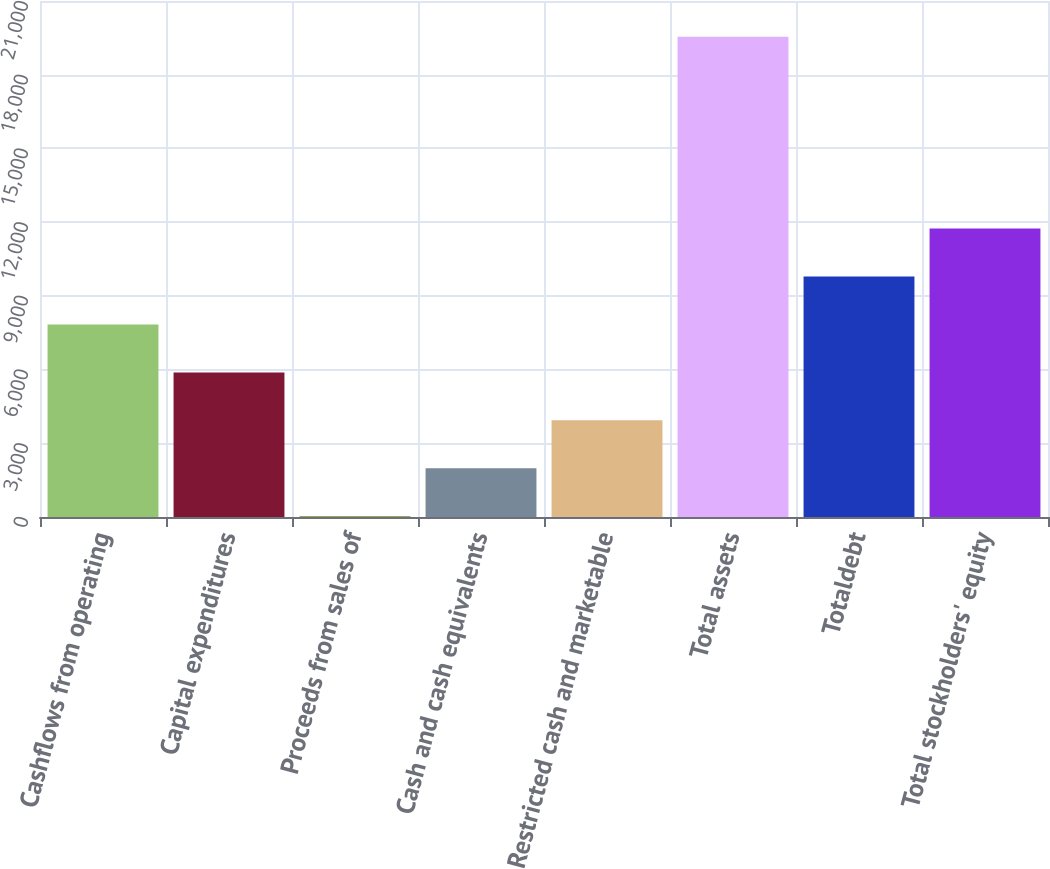Convert chart. <chart><loc_0><loc_0><loc_500><loc_500><bar_chart><fcel>Cashflows from operating<fcel>Capital expenditures<fcel>Proceeds from sales of<fcel>Cash and cash equivalents<fcel>Restricted cash and marketable<fcel>Total assets<fcel>Totaldebt<fcel>Total stockholders' equity<nl><fcel>7835.2<fcel>5884.35<fcel>31.8<fcel>1982.65<fcel>3933.5<fcel>19540.3<fcel>9786.05<fcel>11736.9<nl></chart> 